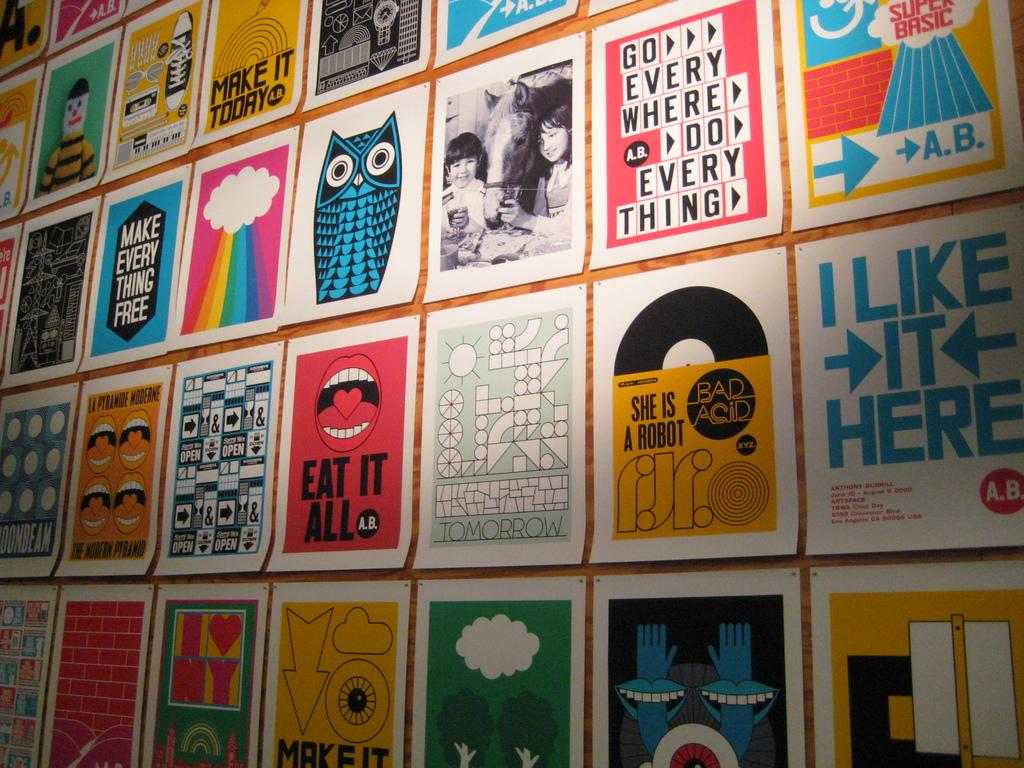<image>
Write a terse but informative summary of the picture. some blue text on paper that says I like it here 